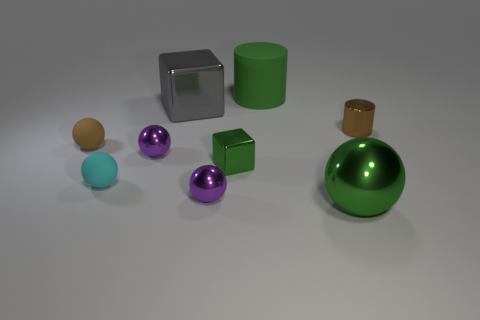Subtract all big spheres. How many spheres are left? 4 Subtract all yellow cylinders. How many purple spheres are left? 2 Subtract 1 balls. How many balls are left? 4 Subtract all green balls. How many balls are left? 4 Subtract all blocks. How many objects are left? 7 Subtract all purple balls. Subtract all green blocks. How many balls are left? 3 Subtract all large green rubber cylinders. Subtract all big gray metallic blocks. How many objects are left? 7 Add 5 big metal spheres. How many big metal spheres are left? 6 Add 6 red things. How many red things exist? 6 Subtract 1 cyan spheres. How many objects are left? 8 